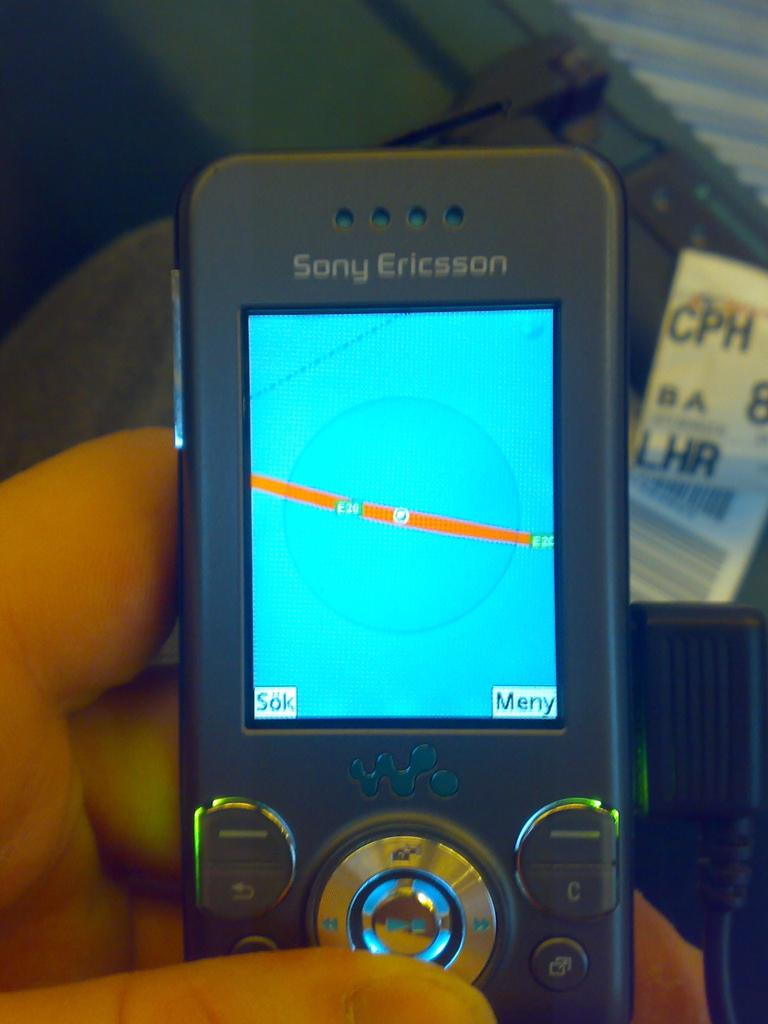<image>
Summarize the visual content of the image. A Sony Ericason phone that has a blue screen with a orange line in the middle of it 